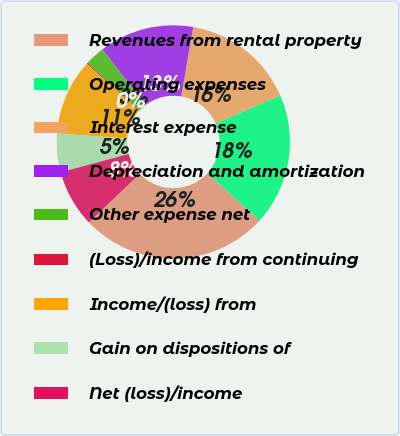<chart> <loc_0><loc_0><loc_500><loc_500><pie_chart><fcel>Revenues from rental property<fcel>Operating expenses<fcel>Interest expense<fcel>Depreciation and amortization<fcel>Other expense net<fcel>(Loss)/income from continuing<fcel>Income/(loss) from<fcel>Gain on dispositions of<fcel>Net (loss)/income<nl><fcel>26.1%<fcel>18.32%<fcel>15.72%<fcel>13.13%<fcel>2.75%<fcel>0.16%<fcel>10.53%<fcel>5.35%<fcel>7.94%<nl></chart> 